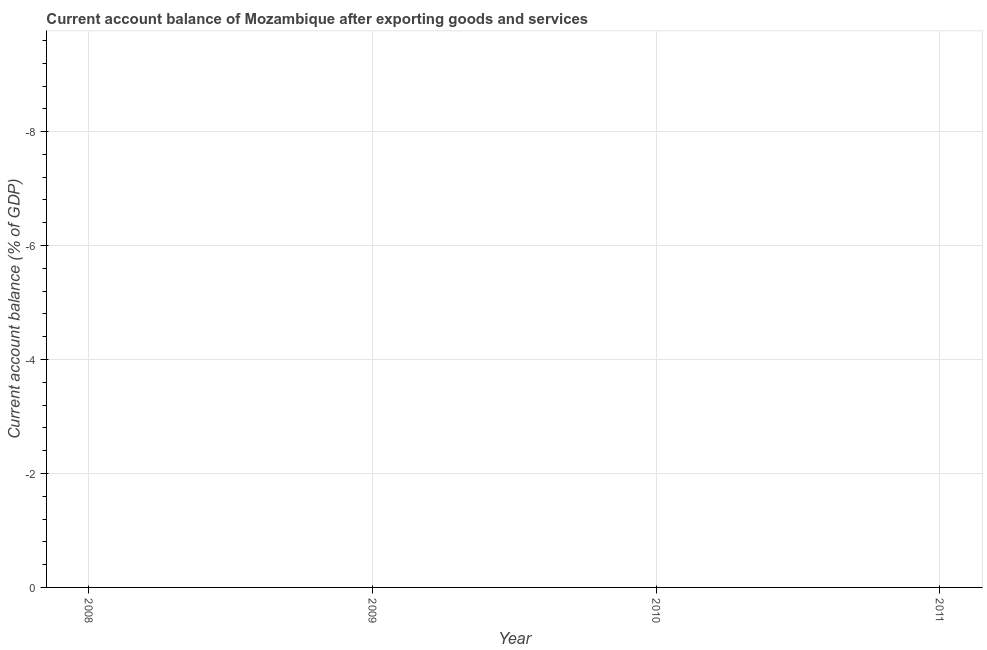What is the current account balance in 2011?
Your answer should be compact. 0. Across all years, what is the minimum current account balance?
Make the answer very short. 0. What is the sum of the current account balance?
Your answer should be very brief. 0. What is the average current account balance per year?
Offer a very short reply. 0. In how many years, is the current account balance greater than the average current account balance taken over all years?
Your answer should be very brief. 0. How many dotlines are there?
Your response must be concise. 0. Are the values on the major ticks of Y-axis written in scientific E-notation?
Keep it short and to the point. No. Does the graph contain grids?
Your response must be concise. Yes. What is the title of the graph?
Offer a terse response. Current account balance of Mozambique after exporting goods and services. What is the label or title of the X-axis?
Your answer should be very brief. Year. What is the label or title of the Y-axis?
Give a very brief answer. Current account balance (% of GDP). What is the Current account balance (% of GDP) in 2009?
Make the answer very short. 0. What is the Current account balance (% of GDP) in 2010?
Keep it short and to the point. 0. 